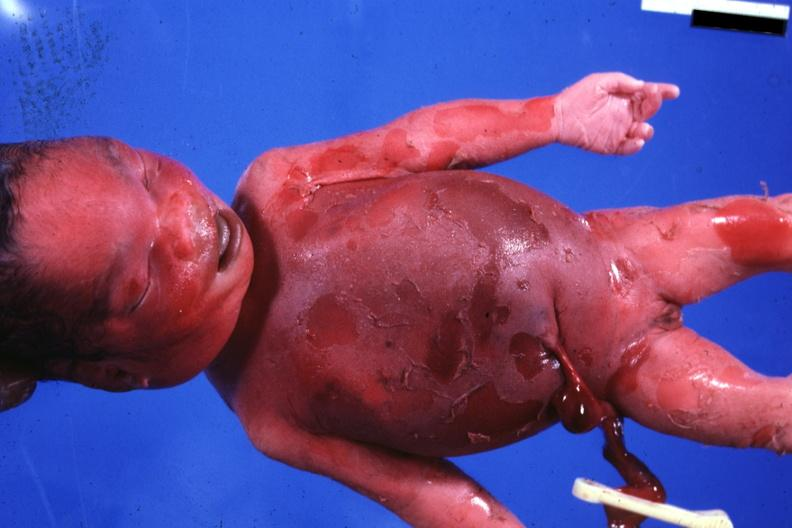s metastatic carcinoma prostate present?
Answer the question using a single word or phrase. No 